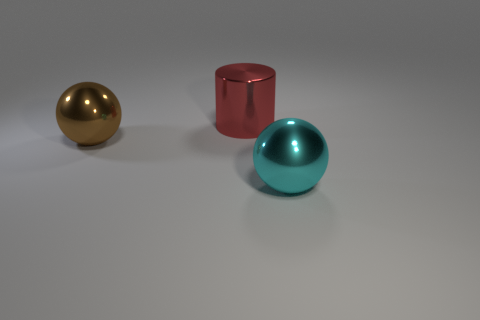Subtract all cyan cylinders. Subtract all green blocks. How many cylinders are left? 1 Add 2 brown shiny spheres. How many objects exist? 5 Subtract all balls. How many objects are left? 1 Subtract 0 yellow cylinders. How many objects are left? 3 Subtract all brown balls. Subtract all small shiny cylinders. How many objects are left? 2 Add 1 metallic spheres. How many metallic spheres are left? 3 Add 1 small purple matte cylinders. How many small purple matte cylinders exist? 1 